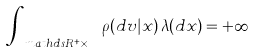<formula> <loc_0><loc_0><loc_500><loc_500>\int _ { \ m a t h d s { R } ^ { + } \times \mathbb { X } } \rho ( d v | x ) \, \lambda ( d x ) = + \infty</formula> 